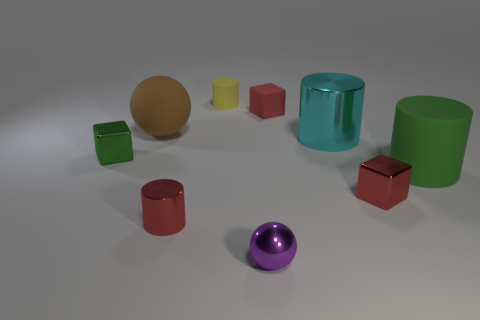Subtract all tiny red blocks. How many blocks are left? 1 Add 1 big metallic blocks. How many objects exist? 10 Subtract 1 spheres. How many spheres are left? 1 Subtract all red cylinders. How many cylinders are left? 3 Subtract all cylinders. How many objects are left? 5 Subtract all yellow blocks. Subtract all brown cylinders. How many blocks are left? 3 Subtract all blue spheres. How many yellow cylinders are left? 1 Subtract all cyan metal things. Subtract all red rubber blocks. How many objects are left? 7 Add 1 small yellow cylinders. How many small yellow cylinders are left? 2 Add 7 tiny green metallic objects. How many tiny green metallic objects exist? 8 